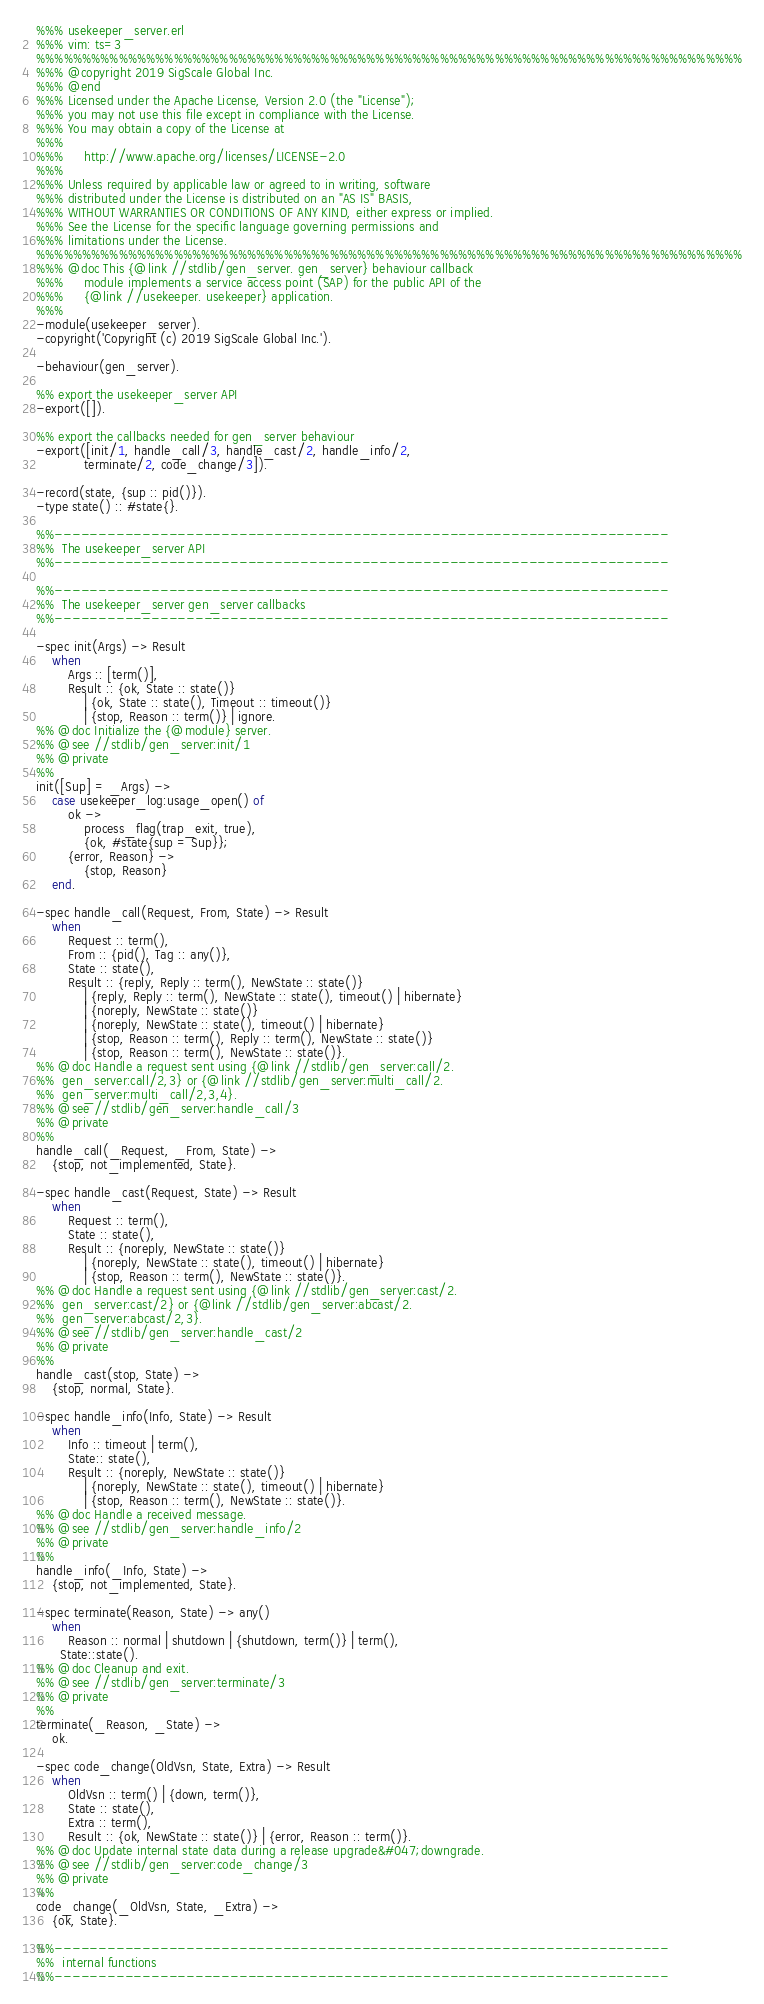<code> <loc_0><loc_0><loc_500><loc_500><_Erlang_>%%% usekeeper_server.erl
%%% vim: ts=3
%%%%%%%%%%%%%%%%%%%%%%%%%%%%%%%%%%%%%%%%%%%%%%%%%%%%%%%%%%%%%%%%%%%%%%%%%%%%%
%%% @copyright 2019 SigScale Global Inc.
%%% @end
%%% Licensed under the Apache License, Version 2.0 (the "License");
%%% you may not use this file except in compliance with the License.
%%% You may obtain a copy of the License at
%%%
%%%     http://www.apache.org/licenses/LICENSE-2.0
%%%
%%% Unless required by applicable law or agreed to in writing, software
%%% distributed under the License is distributed on an "AS IS" BASIS,
%%% WITHOUT WARRANTIES OR CONDITIONS OF ANY KIND, either express or implied.
%%% See the License for the specific language governing permissions and
%%% limitations under the License.
%%%%%%%%%%%%%%%%%%%%%%%%%%%%%%%%%%%%%%%%%%%%%%%%%%%%%%%%%%%%%%%%%%%%%%%%%%%%%
%%% @doc This {@link //stdlib/gen_server. gen_server} behaviour callback
%%% 	module implements a service access point (SAP) for the public API of the
%%% 	{@link //usekeeper. usekeeper} application.
%%%
-module(usekeeper_server).
-copyright('Copyright (c) 2019 SigScale Global Inc.').

-behaviour(gen_server).

%% export the usekeeper_server API
-export([]).

%% export the callbacks needed for gen_server behaviour
-export([init/1, handle_call/3, handle_cast/2, handle_info/2,
			terminate/2, code_change/3]).

-record(state, {sup :: pid()}).
-type state() :: #state{}.

%%----------------------------------------------------------------------
%%  The usekeeper_server API
%%----------------------------------------------------------------------

%%----------------------------------------------------------------------
%%  The usekeeper_server gen_server callbacks
%%----------------------------------------------------------------------

-spec init(Args) -> Result
	when
		Args :: [term()],
		Result :: {ok, State :: state()}
			| {ok, State :: state(), Timeout :: timeout()}
			| {stop, Reason :: term()} | ignore.
%% @doc Initialize the {@module} server.
%% @see //stdlib/gen_server:init/1
%% @private
%%
init([Sup] = _Args) ->
	case usekeeper_log:usage_open() of
		ok ->
			process_flag(trap_exit, true),
			{ok, #state{sup = Sup}};
		{error, Reason} ->
			{stop, Reason}
	end.

-spec handle_call(Request, From, State) -> Result
	when
		Request :: term(),
		From :: {pid(), Tag :: any()},
		State :: state(),
		Result :: {reply, Reply :: term(), NewState :: state()}
			| {reply, Reply :: term(), NewState :: state(), timeout() | hibernate}
			| {noreply, NewState :: state()}
			| {noreply, NewState :: state(), timeout() | hibernate}
			| {stop, Reason :: term(), Reply :: term(), NewState :: state()}
			| {stop, Reason :: term(), NewState :: state()}.
%% @doc Handle a request sent using {@link //stdlib/gen_server:call/2.
%% 	gen_server:call/2,3} or {@link //stdlib/gen_server:multi_call/2.
%% 	gen_server:multi_call/2,3,4}.
%% @see //stdlib/gen_server:handle_call/3
%% @private
%%
handle_call(_Request, _From, State) ->
	{stop, not_implemented, State}.

-spec handle_cast(Request, State) -> Result
	when
		Request :: term(),
		State :: state(),
		Result :: {noreply, NewState :: state()}
			| {noreply, NewState :: state(), timeout() | hibernate}
			| {stop, Reason :: term(), NewState :: state()}.
%% @doc Handle a request sent using {@link //stdlib/gen_server:cast/2.
%% 	gen_server:cast/2} or {@link //stdlib/gen_server:abcast/2.
%% 	gen_server:abcast/2,3}.
%% @see //stdlib/gen_server:handle_cast/2
%% @private
%%
handle_cast(stop, State) ->
	{stop, normal, State}.

-spec handle_info(Info, State) -> Result
	when
		Info :: timeout | term(),
		State:: state(),
		Result :: {noreply, NewState :: state()}
			| {noreply, NewState :: state(), timeout() | hibernate}
			| {stop, Reason :: term(), NewState :: state()}.
%% @doc Handle a received message.
%% @see //stdlib/gen_server:handle_info/2
%% @private
%%
handle_info(_Info, State) ->
	{stop, not_implemented, State}.

-spec terminate(Reason, State) -> any()
	when
		Reason :: normal | shutdown | {shutdown, term()} | term(),
      State::state().
%% @doc Cleanup and exit.
%% @see //stdlib/gen_server:terminate/3
%% @private
%%
terminate(_Reason, _State) ->
	ok.

-spec code_change(OldVsn, State, Extra) -> Result
	when
		OldVsn :: term() | {down, term()},
		State :: state(),
		Extra :: term(),
		Result :: {ok, NewState :: state()} | {error, Reason :: term()}.
%% @doc Update internal state data during a release upgrade&#047;downgrade.
%% @see //stdlib/gen_server:code_change/3
%% @private
%%
code_change(_OldVsn, State, _Extra) ->
	{ok, State}.

%%----------------------------------------------------------------------
%%  internal functions
%%----------------------------------------------------------------------

</code> 